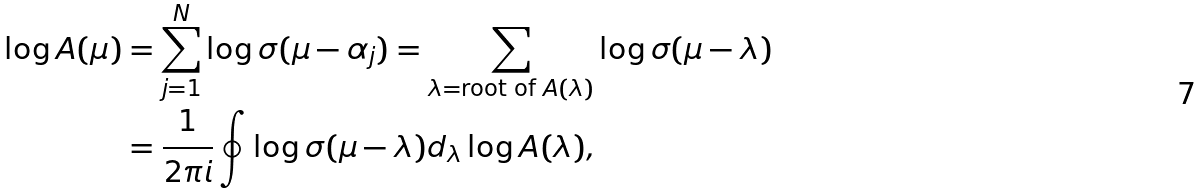<formula> <loc_0><loc_0><loc_500><loc_500>\log A ( \mu ) & = \sum _ { j = 1 } ^ { N } \log \sigma ( \mu - \alpha _ { j } ) = \sum _ { \lambda = \text {root of $A(\lambda)$} } \log \sigma ( \mu - \lambda ) \\ & = \frac { 1 } { 2 \pi i } \oint \log \sigma ( \mu - \lambda ) d _ { \lambda } \log A ( \lambda ) ,</formula> 